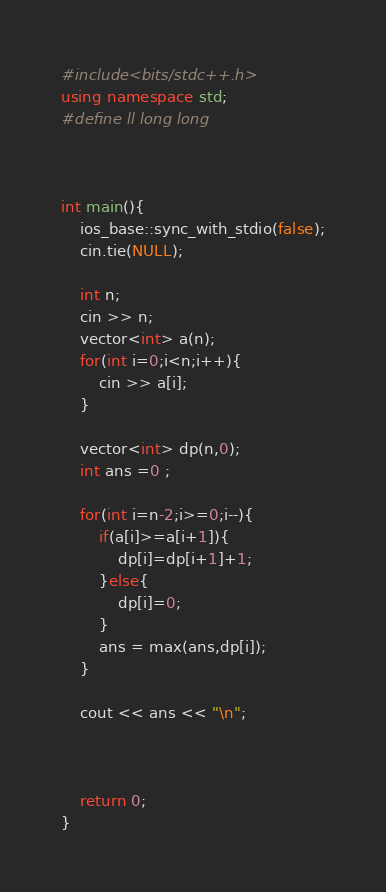Convert code to text. <code><loc_0><loc_0><loc_500><loc_500><_C++_>#include<bits/stdc++.h>
using namespace std;
#define ll long long



int main(){
	ios_base::sync_with_stdio(false);
    cin.tie(NULL);	

    int n;
    cin >> n;
    vector<int> a(n);
    for(int i=0;i<n;i++){
    	cin >> a[i];
    }

    vector<int> dp(n,0);
    int ans =0 ;

    for(int i=n-2;i>=0;i--){
    	if(a[i]>=a[i+1]){
    		dp[i]=dp[i+1]+1;
    	}else{
    		dp[i]=0;
    	}
    	ans = max(ans,dp[i]);
    }

    cout << ans << "\n";


    
	return 0;
}</code> 